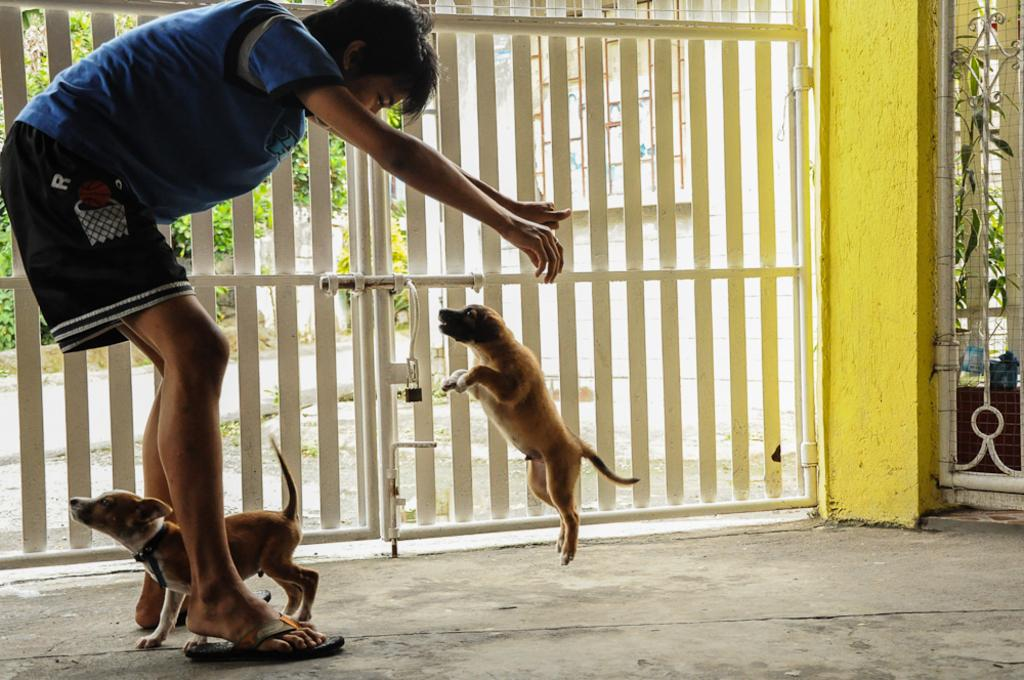Who is present in the image? There is a person in the image. What can be observed about the person's clothing? The person is wearing colorful clothes. What type of footwear is the person wearing? The person is wearing footwear. What activity is the person engaged in? The person is playing with dogs. What natural element can be seen in the background? There is a tree visible behind a gate. What type of industry can be seen in the image? There is no industry present in the image; it features a person playing with dogs and a tree in the background. What type of learning is the person engaged in with the wren? There is no wren present in the image, and the person is playing with dogs, not engaging in any learning activity. 